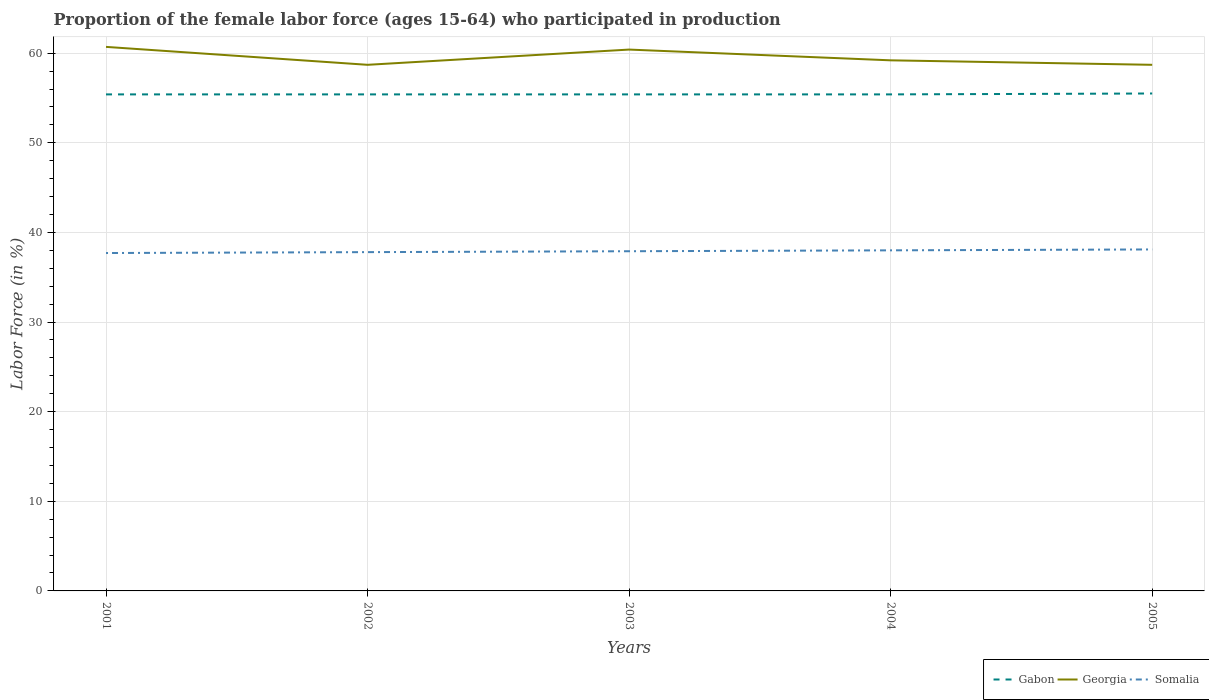Does the line corresponding to Somalia intersect with the line corresponding to Gabon?
Your answer should be compact. No. Across all years, what is the maximum proportion of the female labor force who participated in production in Georgia?
Offer a terse response. 58.7. In which year was the proportion of the female labor force who participated in production in Gabon maximum?
Make the answer very short. 2001. What is the total proportion of the female labor force who participated in production in Georgia in the graph?
Provide a succinct answer. -1.7. What is the difference between the highest and the second highest proportion of the female labor force who participated in production in Georgia?
Your answer should be compact. 2. How many years are there in the graph?
Give a very brief answer. 5. What is the difference between two consecutive major ticks on the Y-axis?
Your response must be concise. 10. Does the graph contain grids?
Make the answer very short. Yes. How are the legend labels stacked?
Your answer should be compact. Horizontal. What is the title of the graph?
Your response must be concise. Proportion of the female labor force (ages 15-64) who participated in production. Does "Kyrgyz Republic" appear as one of the legend labels in the graph?
Your answer should be very brief. No. What is the label or title of the X-axis?
Provide a short and direct response. Years. What is the Labor Force (in %) in Gabon in 2001?
Offer a terse response. 55.4. What is the Labor Force (in %) in Georgia in 2001?
Ensure brevity in your answer.  60.7. What is the Labor Force (in %) in Somalia in 2001?
Your response must be concise. 37.7. What is the Labor Force (in %) in Gabon in 2002?
Offer a very short reply. 55.4. What is the Labor Force (in %) in Georgia in 2002?
Your response must be concise. 58.7. What is the Labor Force (in %) of Somalia in 2002?
Keep it short and to the point. 37.8. What is the Labor Force (in %) of Gabon in 2003?
Your answer should be compact. 55.4. What is the Labor Force (in %) of Georgia in 2003?
Your response must be concise. 60.4. What is the Labor Force (in %) of Somalia in 2003?
Keep it short and to the point. 37.9. What is the Labor Force (in %) of Gabon in 2004?
Your answer should be very brief. 55.4. What is the Labor Force (in %) of Georgia in 2004?
Ensure brevity in your answer.  59.2. What is the Labor Force (in %) in Somalia in 2004?
Make the answer very short. 38. What is the Labor Force (in %) of Gabon in 2005?
Your answer should be very brief. 55.5. What is the Labor Force (in %) of Georgia in 2005?
Keep it short and to the point. 58.7. What is the Labor Force (in %) of Somalia in 2005?
Keep it short and to the point. 38.1. Across all years, what is the maximum Labor Force (in %) of Gabon?
Your response must be concise. 55.5. Across all years, what is the maximum Labor Force (in %) of Georgia?
Provide a short and direct response. 60.7. Across all years, what is the maximum Labor Force (in %) of Somalia?
Offer a very short reply. 38.1. Across all years, what is the minimum Labor Force (in %) in Gabon?
Provide a succinct answer. 55.4. Across all years, what is the minimum Labor Force (in %) of Georgia?
Your answer should be very brief. 58.7. Across all years, what is the minimum Labor Force (in %) of Somalia?
Provide a succinct answer. 37.7. What is the total Labor Force (in %) of Gabon in the graph?
Ensure brevity in your answer.  277.1. What is the total Labor Force (in %) of Georgia in the graph?
Offer a very short reply. 297.7. What is the total Labor Force (in %) of Somalia in the graph?
Offer a very short reply. 189.5. What is the difference between the Labor Force (in %) of Gabon in 2001 and that in 2002?
Offer a very short reply. 0. What is the difference between the Labor Force (in %) of Somalia in 2001 and that in 2002?
Provide a short and direct response. -0.1. What is the difference between the Labor Force (in %) in Gabon in 2001 and that in 2003?
Provide a succinct answer. 0. What is the difference between the Labor Force (in %) in Georgia in 2001 and that in 2004?
Make the answer very short. 1.5. What is the difference between the Labor Force (in %) of Gabon in 2001 and that in 2005?
Provide a succinct answer. -0.1. What is the difference between the Labor Force (in %) in Georgia in 2002 and that in 2003?
Your response must be concise. -1.7. What is the difference between the Labor Force (in %) in Gabon in 2002 and that in 2004?
Offer a very short reply. 0. What is the difference between the Labor Force (in %) of Somalia in 2002 and that in 2004?
Make the answer very short. -0.2. What is the difference between the Labor Force (in %) in Georgia in 2003 and that in 2004?
Ensure brevity in your answer.  1.2. What is the difference between the Labor Force (in %) in Somalia in 2003 and that in 2004?
Ensure brevity in your answer.  -0.1. What is the difference between the Labor Force (in %) in Gabon in 2003 and that in 2005?
Give a very brief answer. -0.1. What is the difference between the Labor Force (in %) of Somalia in 2004 and that in 2005?
Offer a terse response. -0.1. What is the difference between the Labor Force (in %) of Georgia in 2001 and the Labor Force (in %) of Somalia in 2002?
Your response must be concise. 22.9. What is the difference between the Labor Force (in %) of Gabon in 2001 and the Labor Force (in %) of Somalia in 2003?
Offer a terse response. 17.5. What is the difference between the Labor Force (in %) in Georgia in 2001 and the Labor Force (in %) in Somalia in 2003?
Offer a terse response. 22.8. What is the difference between the Labor Force (in %) in Georgia in 2001 and the Labor Force (in %) in Somalia in 2004?
Keep it short and to the point. 22.7. What is the difference between the Labor Force (in %) of Gabon in 2001 and the Labor Force (in %) of Georgia in 2005?
Provide a succinct answer. -3.3. What is the difference between the Labor Force (in %) of Georgia in 2001 and the Labor Force (in %) of Somalia in 2005?
Offer a very short reply. 22.6. What is the difference between the Labor Force (in %) of Georgia in 2002 and the Labor Force (in %) of Somalia in 2003?
Ensure brevity in your answer.  20.8. What is the difference between the Labor Force (in %) of Georgia in 2002 and the Labor Force (in %) of Somalia in 2004?
Ensure brevity in your answer.  20.7. What is the difference between the Labor Force (in %) of Gabon in 2002 and the Labor Force (in %) of Georgia in 2005?
Offer a very short reply. -3.3. What is the difference between the Labor Force (in %) in Gabon in 2002 and the Labor Force (in %) in Somalia in 2005?
Keep it short and to the point. 17.3. What is the difference between the Labor Force (in %) of Georgia in 2002 and the Labor Force (in %) of Somalia in 2005?
Provide a succinct answer. 20.6. What is the difference between the Labor Force (in %) in Gabon in 2003 and the Labor Force (in %) in Somalia in 2004?
Your answer should be very brief. 17.4. What is the difference between the Labor Force (in %) of Georgia in 2003 and the Labor Force (in %) of Somalia in 2004?
Your answer should be compact. 22.4. What is the difference between the Labor Force (in %) in Georgia in 2003 and the Labor Force (in %) in Somalia in 2005?
Provide a short and direct response. 22.3. What is the difference between the Labor Force (in %) in Gabon in 2004 and the Labor Force (in %) in Georgia in 2005?
Provide a succinct answer. -3.3. What is the difference between the Labor Force (in %) in Gabon in 2004 and the Labor Force (in %) in Somalia in 2005?
Your answer should be compact. 17.3. What is the difference between the Labor Force (in %) in Georgia in 2004 and the Labor Force (in %) in Somalia in 2005?
Ensure brevity in your answer.  21.1. What is the average Labor Force (in %) in Gabon per year?
Provide a short and direct response. 55.42. What is the average Labor Force (in %) in Georgia per year?
Your answer should be compact. 59.54. What is the average Labor Force (in %) of Somalia per year?
Make the answer very short. 37.9. In the year 2001, what is the difference between the Labor Force (in %) in Gabon and Labor Force (in %) in Georgia?
Ensure brevity in your answer.  -5.3. In the year 2001, what is the difference between the Labor Force (in %) in Gabon and Labor Force (in %) in Somalia?
Your answer should be very brief. 17.7. In the year 2002, what is the difference between the Labor Force (in %) in Gabon and Labor Force (in %) in Georgia?
Offer a terse response. -3.3. In the year 2002, what is the difference between the Labor Force (in %) in Gabon and Labor Force (in %) in Somalia?
Offer a very short reply. 17.6. In the year 2002, what is the difference between the Labor Force (in %) in Georgia and Labor Force (in %) in Somalia?
Ensure brevity in your answer.  20.9. In the year 2003, what is the difference between the Labor Force (in %) in Georgia and Labor Force (in %) in Somalia?
Ensure brevity in your answer.  22.5. In the year 2004, what is the difference between the Labor Force (in %) in Gabon and Labor Force (in %) in Georgia?
Provide a short and direct response. -3.8. In the year 2004, what is the difference between the Labor Force (in %) in Gabon and Labor Force (in %) in Somalia?
Give a very brief answer. 17.4. In the year 2004, what is the difference between the Labor Force (in %) of Georgia and Labor Force (in %) of Somalia?
Keep it short and to the point. 21.2. In the year 2005, what is the difference between the Labor Force (in %) of Gabon and Labor Force (in %) of Georgia?
Your response must be concise. -3.2. In the year 2005, what is the difference between the Labor Force (in %) in Georgia and Labor Force (in %) in Somalia?
Offer a very short reply. 20.6. What is the ratio of the Labor Force (in %) of Georgia in 2001 to that in 2002?
Your response must be concise. 1.03. What is the ratio of the Labor Force (in %) in Somalia in 2001 to that in 2002?
Give a very brief answer. 1. What is the ratio of the Labor Force (in %) in Gabon in 2001 to that in 2003?
Ensure brevity in your answer.  1. What is the ratio of the Labor Force (in %) of Gabon in 2001 to that in 2004?
Provide a short and direct response. 1. What is the ratio of the Labor Force (in %) in Georgia in 2001 to that in 2004?
Provide a succinct answer. 1.03. What is the ratio of the Labor Force (in %) of Somalia in 2001 to that in 2004?
Offer a terse response. 0.99. What is the ratio of the Labor Force (in %) of Gabon in 2001 to that in 2005?
Your answer should be very brief. 1. What is the ratio of the Labor Force (in %) of Georgia in 2001 to that in 2005?
Your response must be concise. 1.03. What is the ratio of the Labor Force (in %) in Gabon in 2002 to that in 2003?
Give a very brief answer. 1. What is the ratio of the Labor Force (in %) of Georgia in 2002 to that in 2003?
Your answer should be compact. 0.97. What is the ratio of the Labor Force (in %) in Gabon in 2002 to that in 2004?
Give a very brief answer. 1. What is the ratio of the Labor Force (in %) in Georgia in 2002 to that in 2004?
Offer a very short reply. 0.99. What is the ratio of the Labor Force (in %) of Gabon in 2002 to that in 2005?
Make the answer very short. 1. What is the ratio of the Labor Force (in %) in Georgia in 2003 to that in 2004?
Ensure brevity in your answer.  1.02. What is the ratio of the Labor Force (in %) in Gabon in 2003 to that in 2005?
Give a very brief answer. 1. What is the ratio of the Labor Force (in %) in Somalia in 2003 to that in 2005?
Keep it short and to the point. 0.99. What is the ratio of the Labor Force (in %) of Georgia in 2004 to that in 2005?
Your response must be concise. 1.01. What is the ratio of the Labor Force (in %) in Somalia in 2004 to that in 2005?
Provide a succinct answer. 1. What is the difference between the highest and the second highest Labor Force (in %) of Georgia?
Your answer should be compact. 0.3. What is the difference between the highest and the second highest Labor Force (in %) in Somalia?
Make the answer very short. 0.1. What is the difference between the highest and the lowest Labor Force (in %) of Georgia?
Offer a terse response. 2. 